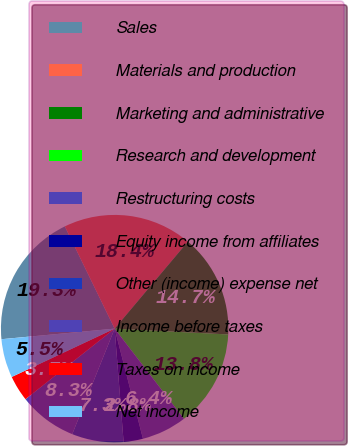Convert chart. <chart><loc_0><loc_0><loc_500><loc_500><pie_chart><fcel>Sales<fcel>Materials and production<fcel>Marketing and administrative<fcel>Research and development<fcel>Restructuring costs<fcel>Equity income from affiliates<fcel>Other (income) expense net<fcel>Income before taxes<fcel>Taxes on income<fcel>Net income<nl><fcel>19.27%<fcel>18.35%<fcel>14.68%<fcel>13.76%<fcel>6.42%<fcel>2.75%<fcel>7.34%<fcel>8.26%<fcel>3.67%<fcel>5.5%<nl></chart> 